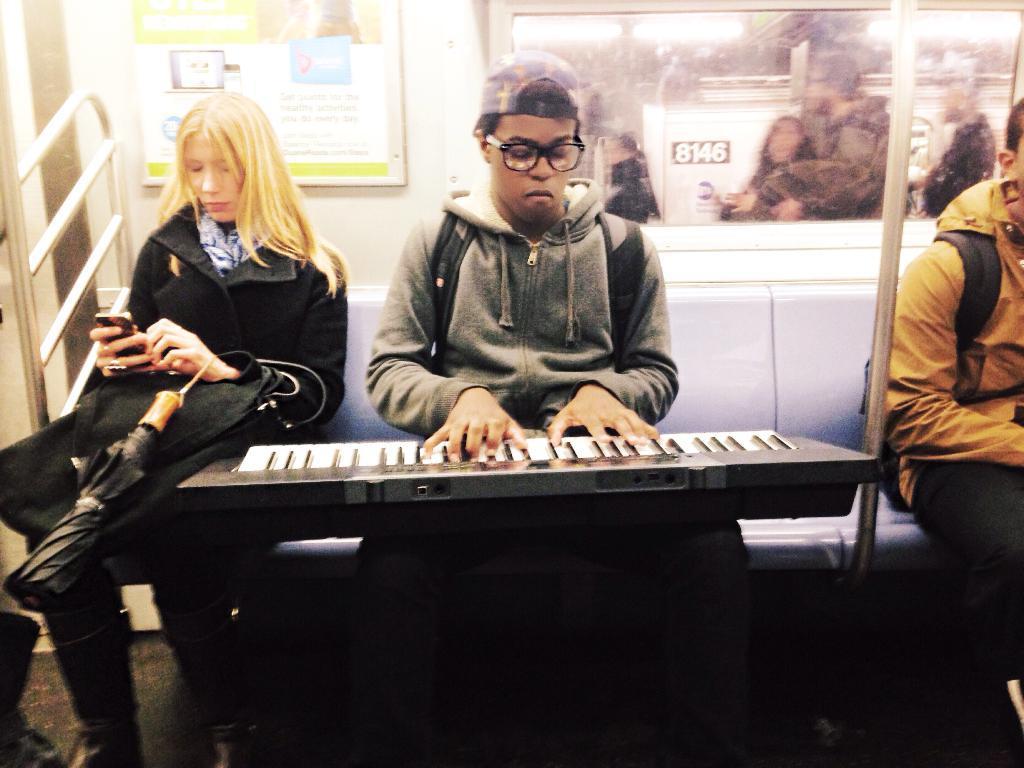Can you describe this image briefly? This man is playing piano keyboard. This woman is holding a umbrella and mobile. A picture inside of a train. From this window we can able to see persons. 